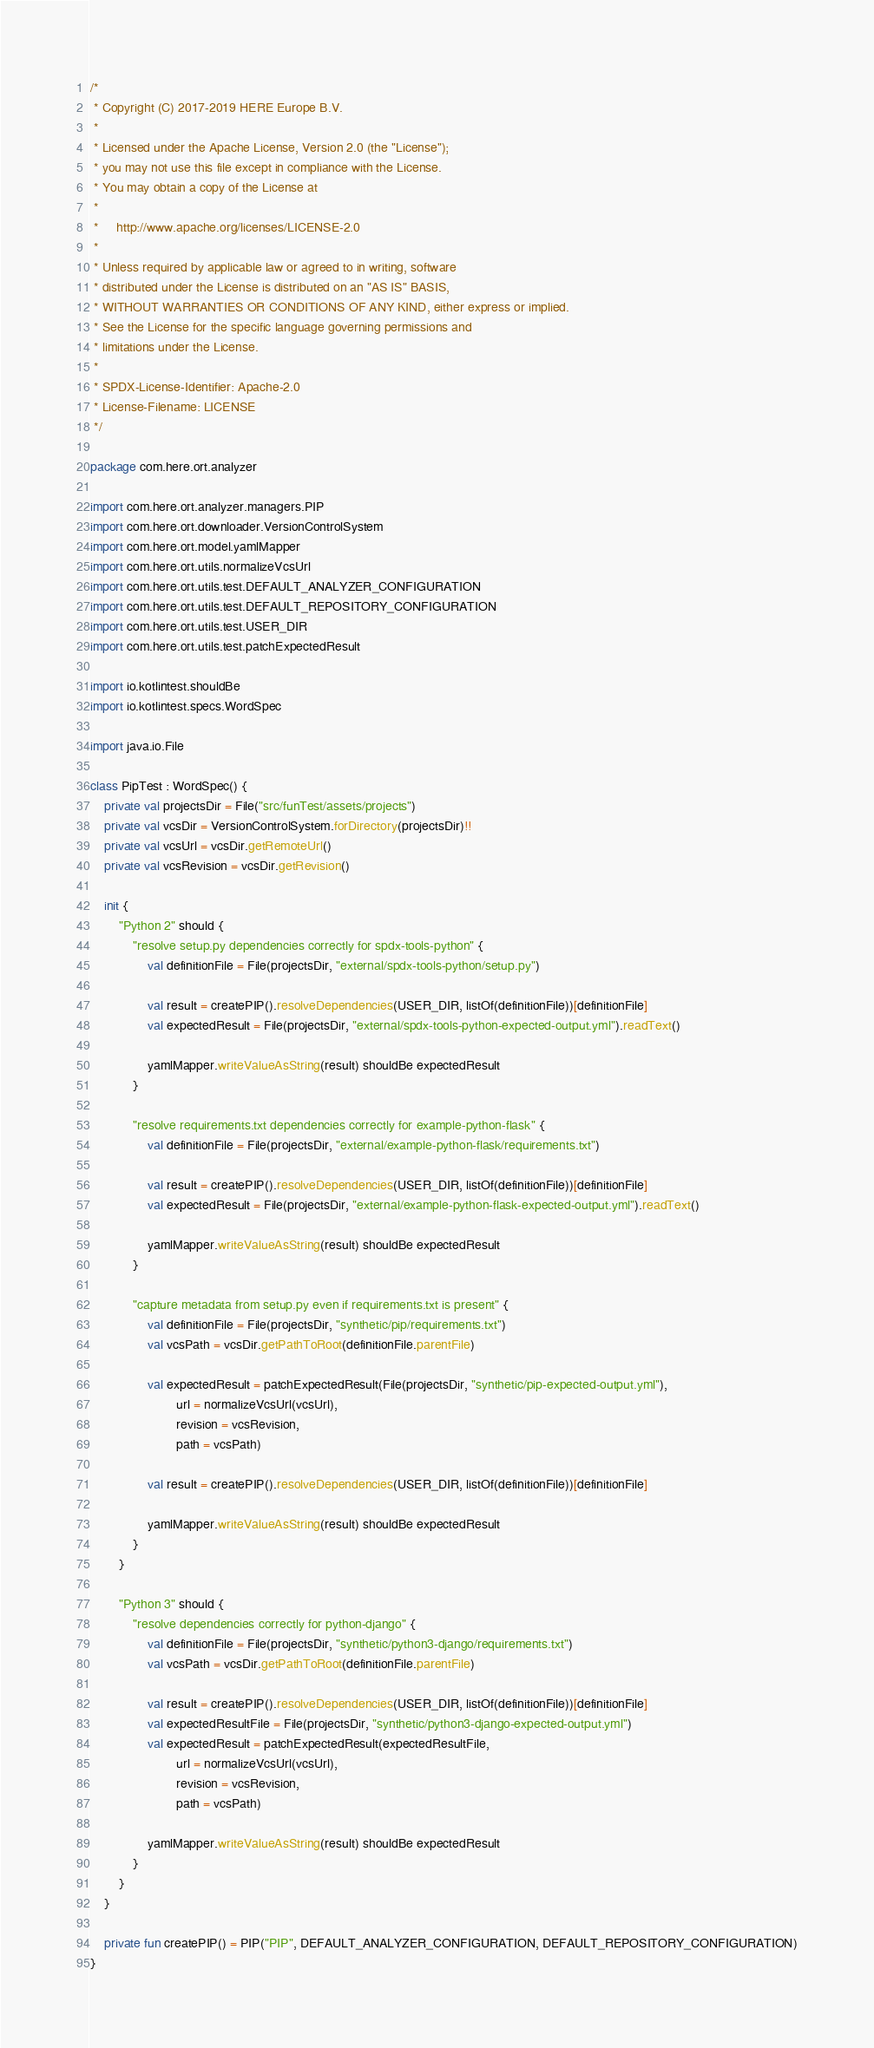<code> <loc_0><loc_0><loc_500><loc_500><_Kotlin_>/*
 * Copyright (C) 2017-2019 HERE Europe B.V.
 *
 * Licensed under the Apache License, Version 2.0 (the "License");
 * you may not use this file except in compliance with the License.
 * You may obtain a copy of the License at
 *
 *     http://www.apache.org/licenses/LICENSE-2.0
 *
 * Unless required by applicable law or agreed to in writing, software
 * distributed under the License is distributed on an "AS IS" BASIS,
 * WITHOUT WARRANTIES OR CONDITIONS OF ANY KIND, either express or implied.
 * See the License for the specific language governing permissions and
 * limitations under the License.
 *
 * SPDX-License-Identifier: Apache-2.0
 * License-Filename: LICENSE
 */

package com.here.ort.analyzer

import com.here.ort.analyzer.managers.PIP
import com.here.ort.downloader.VersionControlSystem
import com.here.ort.model.yamlMapper
import com.here.ort.utils.normalizeVcsUrl
import com.here.ort.utils.test.DEFAULT_ANALYZER_CONFIGURATION
import com.here.ort.utils.test.DEFAULT_REPOSITORY_CONFIGURATION
import com.here.ort.utils.test.USER_DIR
import com.here.ort.utils.test.patchExpectedResult

import io.kotlintest.shouldBe
import io.kotlintest.specs.WordSpec

import java.io.File

class PipTest : WordSpec() {
    private val projectsDir = File("src/funTest/assets/projects")
    private val vcsDir = VersionControlSystem.forDirectory(projectsDir)!!
    private val vcsUrl = vcsDir.getRemoteUrl()
    private val vcsRevision = vcsDir.getRevision()

    init {
        "Python 2" should {
            "resolve setup.py dependencies correctly for spdx-tools-python" {
                val definitionFile = File(projectsDir, "external/spdx-tools-python/setup.py")

                val result = createPIP().resolveDependencies(USER_DIR, listOf(definitionFile))[definitionFile]
                val expectedResult = File(projectsDir, "external/spdx-tools-python-expected-output.yml").readText()

                yamlMapper.writeValueAsString(result) shouldBe expectedResult
            }

            "resolve requirements.txt dependencies correctly for example-python-flask" {
                val definitionFile = File(projectsDir, "external/example-python-flask/requirements.txt")

                val result = createPIP().resolveDependencies(USER_DIR, listOf(definitionFile))[definitionFile]
                val expectedResult = File(projectsDir, "external/example-python-flask-expected-output.yml").readText()

                yamlMapper.writeValueAsString(result) shouldBe expectedResult
            }

            "capture metadata from setup.py even if requirements.txt is present" {
                val definitionFile = File(projectsDir, "synthetic/pip/requirements.txt")
                val vcsPath = vcsDir.getPathToRoot(definitionFile.parentFile)

                val expectedResult = patchExpectedResult(File(projectsDir, "synthetic/pip-expected-output.yml"),
                        url = normalizeVcsUrl(vcsUrl),
                        revision = vcsRevision,
                        path = vcsPath)

                val result = createPIP().resolveDependencies(USER_DIR, listOf(definitionFile))[definitionFile]

                yamlMapper.writeValueAsString(result) shouldBe expectedResult
            }
        }

        "Python 3" should {
            "resolve dependencies correctly for python-django" {
                val definitionFile = File(projectsDir, "synthetic/python3-django/requirements.txt")
                val vcsPath = vcsDir.getPathToRoot(definitionFile.parentFile)

                val result = createPIP().resolveDependencies(USER_DIR, listOf(definitionFile))[definitionFile]
                val expectedResultFile = File(projectsDir, "synthetic/python3-django-expected-output.yml")
                val expectedResult = patchExpectedResult(expectedResultFile,
                        url = normalizeVcsUrl(vcsUrl),
                        revision = vcsRevision,
                        path = vcsPath)

                yamlMapper.writeValueAsString(result) shouldBe expectedResult
            }
        }
    }

    private fun createPIP() = PIP("PIP", DEFAULT_ANALYZER_CONFIGURATION, DEFAULT_REPOSITORY_CONFIGURATION)
}
</code> 